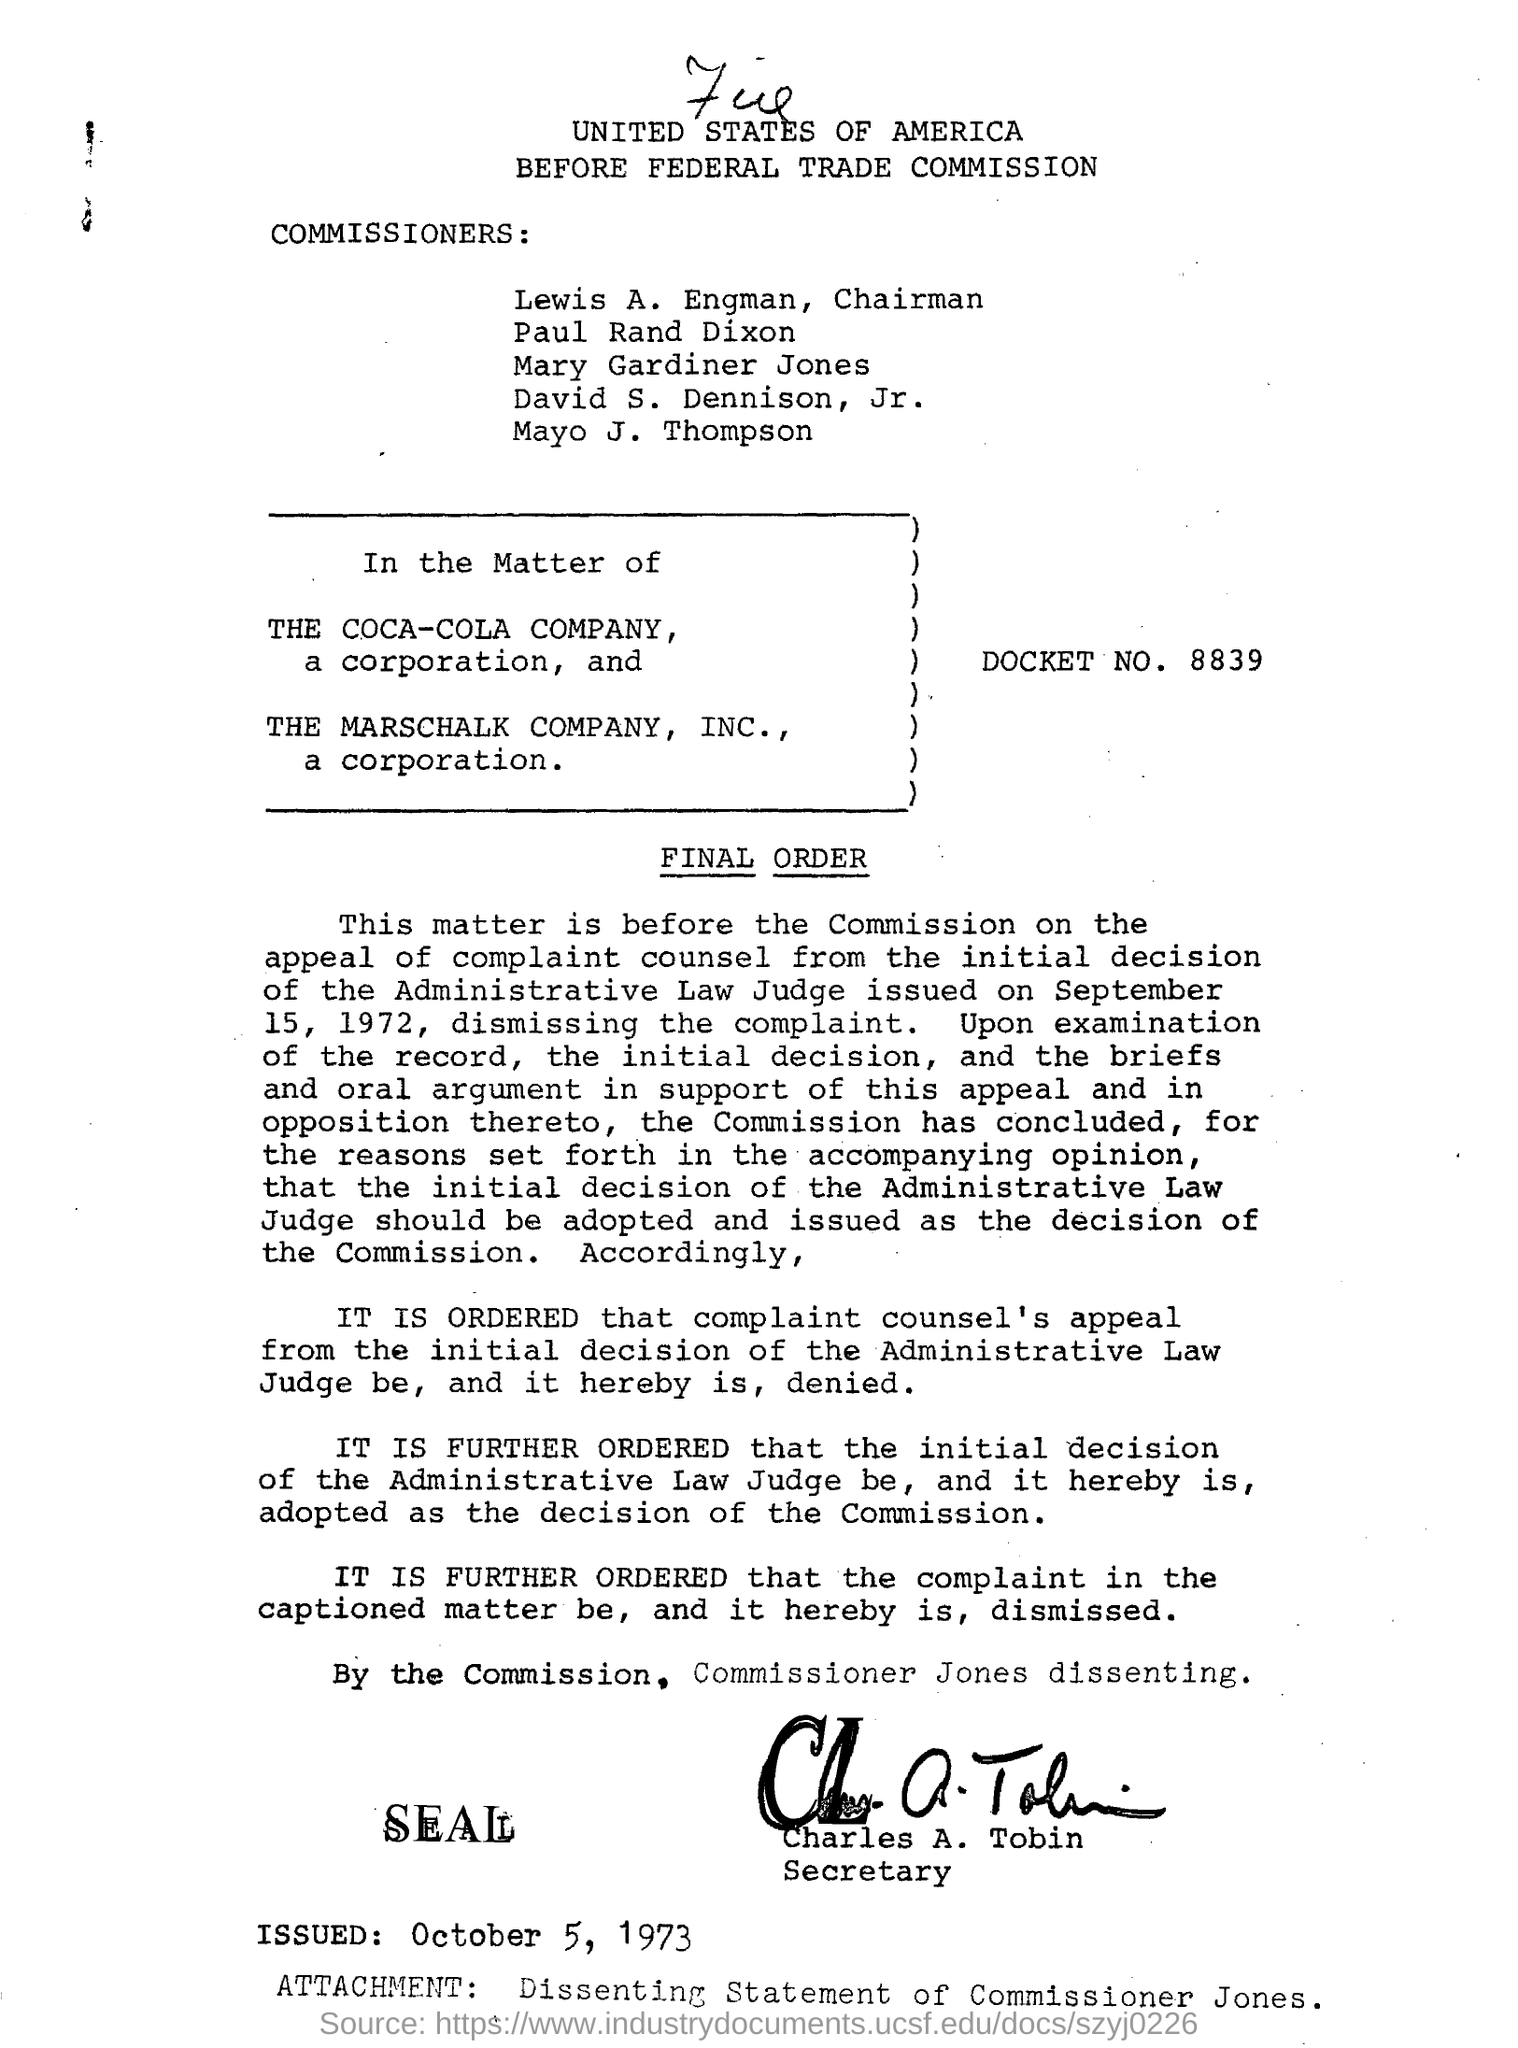What is the DOCKET NO?
Ensure brevity in your answer.  8839. When was this document issued?
Provide a succinct answer. October 5, 1973. Who is the secretary?
Give a very brief answer. Charles A. Tobin. 